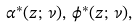Convert formula to latex. <formula><loc_0><loc_0><loc_500><loc_500>\alpha ^ { \ast } ( z ; \, \nu ) , \, \phi ^ { \ast } ( z ; \, \nu ) ,</formula> 